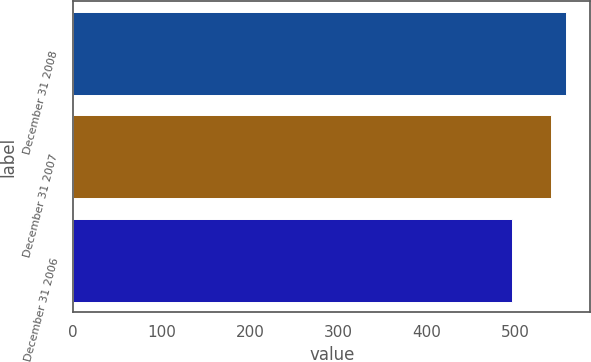Convert chart. <chart><loc_0><loc_0><loc_500><loc_500><bar_chart><fcel>December 31 2008<fcel>December 31 2007<fcel>December 31 2006<nl><fcel>557.3<fcel>541<fcel>496.3<nl></chart> 